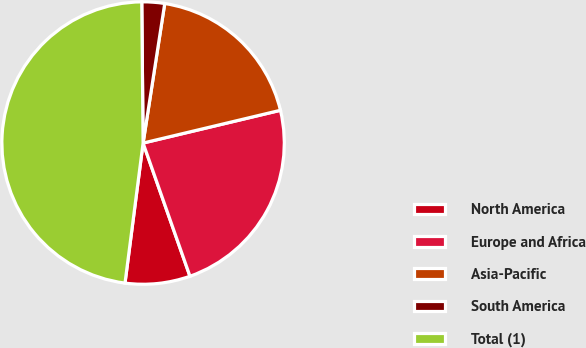Convert chart. <chart><loc_0><loc_0><loc_500><loc_500><pie_chart><fcel>North America<fcel>Europe and Africa<fcel>Asia-Pacific<fcel>South America<fcel>Total (1)<nl><fcel>7.43%<fcel>23.34%<fcel>18.82%<fcel>2.6%<fcel>47.8%<nl></chart> 